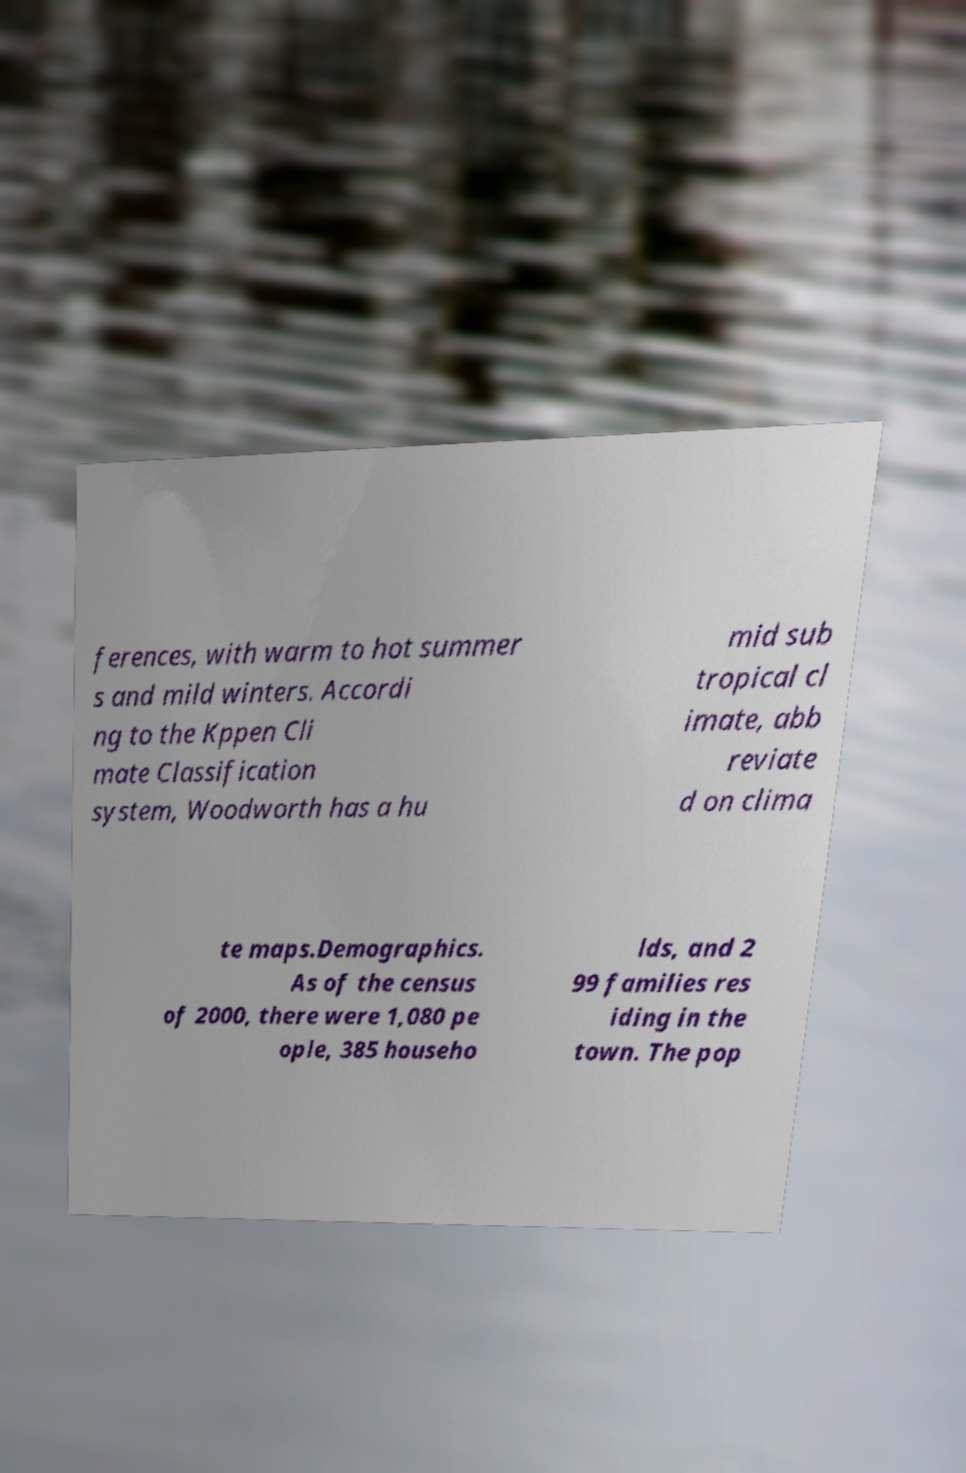I need the written content from this picture converted into text. Can you do that? ferences, with warm to hot summer s and mild winters. Accordi ng to the Kppen Cli mate Classification system, Woodworth has a hu mid sub tropical cl imate, abb reviate d on clima te maps.Demographics. As of the census of 2000, there were 1,080 pe ople, 385 househo lds, and 2 99 families res iding in the town. The pop 